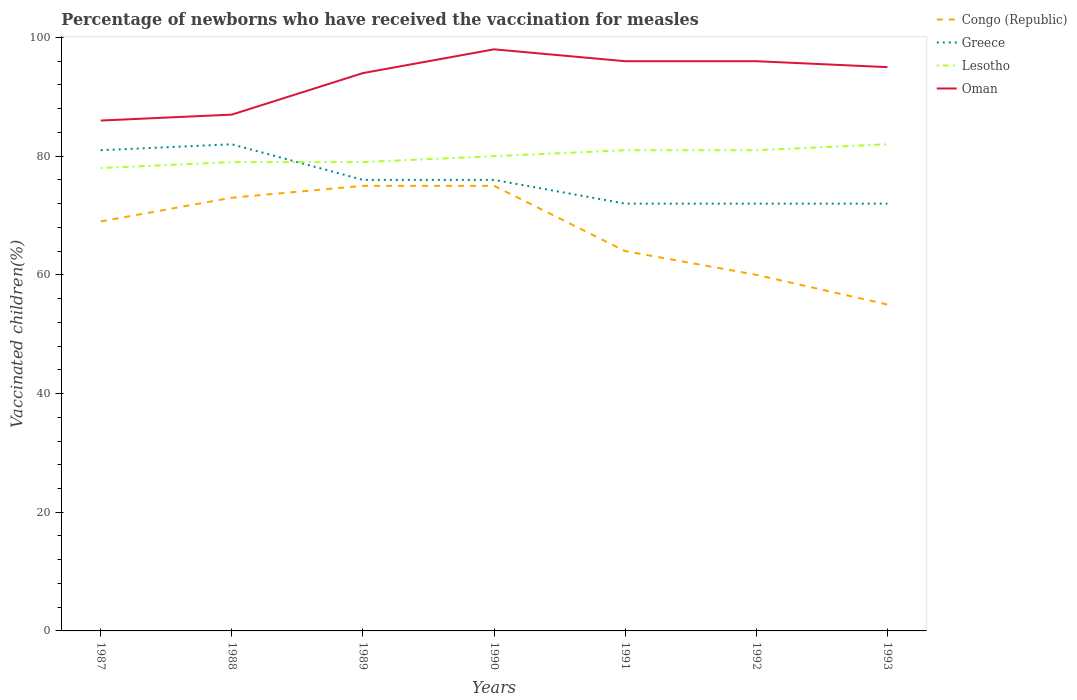Across all years, what is the maximum percentage of vaccinated children in Lesotho?
Your answer should be very brief. 78. In which year was the percentage of vaccinated children in Congo (Republic) maximum?
Provide a succinct answer. 1993. What is the total percentage of vaccinated children in Oman in the graph?
Make the answer very short. -1. What is the difference between the highest and the second highest percentage of vaccinated children in Lesotho?
Make the answer very short. 4. What is the difference between the highest and the lowest percentage of vaccinated children in Greece?
Your answer should be compact. 4. Is the percentage of vaccinated children in Lesotho strictly greater than the percentage of vaccinated children in Greece over the years?
Your answer should be compact. No. How many lines are there?
Offer a terse response. 4. How many years are there in the graph?
Make the answer very short. 7. Are the values on the major ticks of Y-axis written in scientific E-notation?
Give a very brief answer. No. How are the legend labels stacked?
Your answer should be compact. Vertical. What is the title of the graph?
Your response must be concise. Percentage of newborns who have received the vaccination for measles. Does "Turks and Caicos Islands" appear as one of the legend labels in the graph?
Offer a terse response. No. What is the label or title of the X-axis?
Give a very brief answer. Years. What is the label or title of the Y-axis?
Provide a succinct answer. Vaccinated children(%). What is the Vaccinated children(%) of Greece in 1987?
Offer a very short reply. 81. What is the Vaccinated children(%) in Lesotho in 1987?
Offer a very short reply. 78. What is the Vaccinated children(%) in Congo (Republic) in 1988?
Your answer should be very brief. 73. What is the Vaccinated children(%) of Lesotho in 1988?
Keep it short and to the point. 79. What is the Vaccinated children(%) in Congo (Republic) in 1989?
Provide a succinct answer. 75. What is the Vaccinated children(%) of Lesotho in 1989?
Provide a succinct answer. 79. What is the Vaccinated children(%) of Oman in 1989?
Provide a succinct answer. 94. What is the Vaccinated children(%) of Lesotho in 1990?
Provide a short and direct response. 80. What is the Vaccinated children(%) in Oman in 1990?
Give a very brief answer. 98. What is the Vaccinated children(%) of Oman in 1991?
Give a very brief answer. 96. What is the Vaccinated children(%) of Congo (Republic) in 1992?
Offer a very short reply. 60. What is the Vaccinated children(%) in Greece in 1992?
Your answer should be very brief. 72. What is the Vaccinated children(%) of Oman in 1992?
Ensure brevity in your answer.  96. What is the Vaccinated children(%) of Lesotho in 1993?
Your response must be concise. 82. What is the Vaccinated children(%) in Oman in 1993?
Your answer should be compact. 95. Across all years, what is the maximum Vaccinated children(%) in Congo (Republic)?
Your response must be concise. 75. Across all years, what is the maximum Vaccinated children(%) of Greece?
Provide a short and direct response. 82. Across all years, what is the maximum Vaccinated children(%) of Lesotho?
Provide a succinct answer. 82. Across all years, what is the maximum Vaccinated children(%) of Oman?
Provide a short and direct response. 98. Across all years, what is the minimum Vaccinated children(%) in Congo (Republic)?
Make the answer very short. 55. What is the total Vaccinated children(%) of Congo (Republic) in the graph?
Provide a succinct answer. 471. What is the total Vaccinated children(%) of Greece in the graph?
Provide a succinct answer. 531. What is the total Vaccinated children(%) of Lesotho in the graph?
Ensure brevity in your answer.  560. What is the total Vaccinated children(%) of Oman in the graph?
Offer a very short reply. 652. What is the difference between the Vaccinated children(%) in Greece in 1987 and that in 1988?
Your answer should be very brief. -1. What is the difference between the Vaccinated children(%) in Lesotho in 1987 and that in 1988?
Offer a very short reply. -1. What is the difference between the Vaccinated children(%) in Oman in 1987 and that in 1988?
Provide a succinct answer. -1. What is the difference between the Vaccinated children(%) in Congo (Republic) in 1987 and that in 1989?
Keep it short and to the point. -6. What is the difference between the Vaccinated children(%) in Congo (Republic) in 1987 and that in 1990?
Your answer should be very brief. -6. What is the difference between the Vaccinated children(%) in Congo (Republic) in 1987 and that in 1991?
Your answer should be compact. 5. What is the difference between the Vaccinated children(%) in Lesotho in 1987 and that in 1992?
Provide a succinct answer. -3. What is the difference between the Vaccinated children(%) in Oman in 1987 and that in 1992?
Ensure brevity in your answer.  -10. What is the difference between the Vaccinated children(%) of Congo (Republic) in 1987 and that in 1993?
Offer a terse response. 14. What is the difference between the Vaccinated children(%) of Greece in 1987 and that in 1993?
Give a very brief answer. 9. What is the difference between the Vaccinated children(%) in Oman in 1987 and that in 1993?
Provide a succinct answer. -9. What is the difference between the Vaccinated children(%) in Lesotho in 1988 and that in 1989?
Offer a terse response. 0. What is the difference between the Vaccinated children(%) in Oman in 1988 and that in 1989?
Ensure brevity in your answer.  -7. What is the difference between the Vaccinated children(%) in Greece in 1988 and that in 1990?
Offer a terse response. 6. What is the difference between the Vaccinated children(%) of Lesotho in 1988 and that in 1990?
Offer a very short reply. -1. What is the difference between the Vaccinated children(%) of Oman in 1988 and that in 1990?
Provide a succinct answer. -11. What is the difference between the Vaccinated children(%) of Congo (Republic) in 1988 and that in 1991?
Provide a short and direct response. 9. What is the difference between the Vaccinated children(%) in Lesotho in 1988 and that in 1991?
Offer a very short reply. -2. What is the difference between the Vaccinated children(%) in Oman in 1988 and that in 1991?
Make the answer very short. -9. What is the difference between the Vaccinated children(%) in Congo (Republic) in 1988 and that in 1992?
Provide a succinct answer. 13. What is the difference between the Vaccinated children(%) of Oman in 1988 and that in 1992?
Make the answer very short. -9. What is the difference between the Vaccinated children(%) in Lesotho in 1988 and that in 1993?
Give a very brief answer. -3. What is the difference between the Vaccinated children(%) in Oman in 1988 and that in 1993?
Offer a terse response. -8. What is the difference between the Vaccinated children(%) of Lesotho in 1989 and that in 1990?
Make the answer very short. -1. What is the difference between the Vaccinated children(%) in Oman in 1989 and that in 1990?
Your response must be concise. -4. What is the difference between the Vaccinated children(%) of Congo (Republic) in 1989 and that in 1992?
Offer a terse response. 15. What is the difference between the Vaccinated children(%) in Congo (Republic) in 1989 and that in 1993?
Your answer should be very brief. 20. What is the difference between the Vaccinated children(%) of Greece in 1989 and that in 1993?
Give a very brief answer. 4. What is the difference between the Vaccinated children(%) in Lesotho in 1989 and that in 1993?
Offer a terse response. -3. What is the difference between the Vaccinated children(%) in Congo (Republic) in 1990 and that in 1991?
Ensure brevity in your answer.  11. What is the difference between the Vaccinated children(%) in Lesotho in 1990 and that in 1991?
Provide a short and direct response. -1. What is the difference between the Vaccinated children(%) of Lesotho in 1990 and that in 1992?
Your response must be concise. -1. What is the difference between the Vaccinated children(%) of Congo (Republic) in 1990 and that in 1993?
Provide a succinct answer. 20. What is the difference between the Vaccinated children(%) of Congo (Republic) in 1991 and that in 1992?
Your response must be concise. 4. What is the difference between the Vaccinated children(%) in Greece in 1991 and that in 1993?
Give a very brief answer. 0. What is the difference between the Vaccinated children(%) of Congo (Republic) in 1987 and the Vaccinated children(%) of Greece in 1988?
Give a very brief answer. -13. What is the difference between the Vaccinated children(%) of Congo (Republic) in 1987 and the Vaccinated children(%) of Oman in 1988?
Your response must be concise. -18. What is the difference between the Vaccinated children(%) of Greece in 1987 and the Vaccinated children(%) of Lesotho in 1988?
Provide a short and direct response. 2. What is the difference between the Vaccinated children(%) of Congo (Republic) in 1987 and the Vaccinated children(%) of Oman in 1989?
Your answer should be compact. -25. What is the difference between the Vaccinated children(%) in Greece in 1987 and the Vaccinated children(%) in Lesotho in 1989?
Ensure brevity in your answer.  2. What is the difference between the Vaccinated children(%) in Lesotho in 1987 and the Vaccinated children(%) in Oman in 1989?
Make the answer very short. -16. What is the difference between the Vaccinated children(%) of Congo (Republic) in 1987 and the Vaccinated children(%) of Greece in 1990?
Ensure brevity in your answer.  -7. What is the difference between the Vaccinated children(%) in Congo (Republic) in 1987 and the Vaccinated children(%) in Lesotho in 1990?
Your response must be concise. -11. What is the difference between the Vaccinated children(%) of Lesotho in 1987 and the Vaccinated children(%) of Oman in 1990?
Offer a very short reply. -20. What is the difference between the Vaccinated children(%) in Congo (Republic) in 1987 and the Vaccinated children(%) in Lesotho in 1991?
Make the answer very short. -12. What is the difference between the Vaccinated children(%) in Congo (Republic) in 1987 and the Vaccinated children(%) in Greece in 1992?
Your answer should be very brief. -3. What is the difference between the Vaccinated children(%) in Congo (Republic) in 1987 and the Vaccinated children(%) in Oman in 1992?
Keep it short and to the point. -27. What is the difference between the Vaccinated children(%) of Lesotho in 1987 and the Vaccinated children(%) of Oman in 1992?
Provide a short and direct response. -18. What is the difference between the Vaccinated children(%) in Congo (Republic) in 1987 and the Vaccinated children(%) in Greece in 1993?
Provide a succinct answer. -3. What is the difference between the Vaccinated children(%) of Congo (Republic) in 1987 and the Vaccinated children(%) of Lesotho in 1993?
Your response must be concise. -13. What is the difference between the Vaccinated children(%) of Greece in 1987 and the Vaccinated children(%) of Lesotho in 1993?
Ensure brevity in your answer.  -1. What is the difference between the Vaccinated children(%) in Greece in 1987 and the Vaccinated children(%) in Oman in 1993?
Ensure brevity in your answer.  -14. What is the difference between the Vaccinated children(%) of Congo (Republic) in 1988 and the Vaccinated children(%) of Greece in 1989?
Offer a very short reply. -3. What is the difference between the Vaccinated children(%) in Congo (Republic) in 1988 and the Vaccinated children(%) in Oman in 1989?
Keep it short and to the point. -21. What is the difference between the Vaccinated children(%) of Greece in 1988 and the Vaccinated children(%) of Lesotho in 1989?
Make the answer very short. 3. What is the difference between the Vaccinated children(%) of Lesotho in 1988 and the Vaccinated children(%) of Oman in 1989?
Your answer should be compact. -15. What is the difference between the Vaccinated children(%) of Congo (Republic) in 1988 and the Vaccinated children(%) of Greece in 1990?
Offer a very short reply. -3. What is the difference between the Vaccinated children(%) of Lesotho in 1988 and the Vaccinated children(%) of Oman in 1990?
Offer a very short reply. -19. What is the difference between the Vaccinated children(%) in Congo (Republic) in 1988 and the Vaccinated children(%) in Lesotho in 1991?
Offer a terse response. -8. What is the difference between the Vaccinated children(%) of Greece in 1988 and the Vaccinated children(%) of Oman in 1991?
Provide a succinct answer. -14. What is the difference between the Vaccinated children(%) in Lesotho in 1988 and the Vaccinated children(%) in Oman in 1991?
Your answer should be very brief. -17. What is the difference between the Vaccinated children(%) of Congo (Republic) in 1988 and the Vaccinated children(%) of Greece in 1992?
Provide a succinct answer. 1. What is the difference between the Vaccinated children(%) in Congo (Republic) in 1988 and the Vaccinated children(%) in Oman in 1992?
Make the answer very short. -23. What is the difference between the Vaccinated children(%) in Greece in 1988 and the Vaccinated children(%) in Oman in 1992?
Ensure brevity in your answer.  -14. What is the difference between the Vaccinated children(%) of Congo (Republic) in 1988 and the Vaccinated children(%) of Oman in 1993?
Provide a short and direct response. -22. What is the difference between the Vaccinated children(%) of Congo (Republic) in 1989 and the Vaccinated children(%) of Greece in 1990?
Offer a terse response. -1. What is the difference between the Vaccinated children(%) in Congo (Republic) in 1989 and the Vaccinated children(%) in Oman in 1990?
Provide a succinct answer. -23. What is the difference between the Vaccinated children(%) in Greece in 1989 and the Vaccinated children(%) in Oman in 1990?
Keep it short and to the point. -22. What is the difference between the Vaccinated children(%) in Lesotho in 1989 and the Vaccinated children(%) in Oman in 1990?
Keep it short and to the point. -19. What is the difference between the Vaccinated children(%) of Congo (Republic) in 1989 and the Vaccinated children(%) of Lesotho in 1991?
Provide a short and direct response. -6. What is the difference between the Vaccinated children(%) of Congo (Republic) in 1989 and the Vaccinated children(%) of Oman in 1991?
Your answer should be very brief. -21. What is the difference between the Vaccinated children(%) in Congo (Republic) in 1989 and the Vaccinated children(%) in Greece in 1992?
Your answer should be compact. 3. What is the difference between the Vaccinated children(%) in Congo (Republic) in 1989 and the Vaccinated children(%) in Lesotho in 1992?
Give a very brief answer. -6. What is the difference between the Vaccinated children(%) in Congo (Republic) in 1989 and the Vaccinated children(%) in Oman in 1992?
Your answer should be compact. -21. What is the difference between the Vaccinated children(%) in Greece in 1989 and the Vaccinated children(%) in Oman in 1992?
Make the answer very short. -20. What is the difference between the Vaccinated children(%) of Congo (Republic) in 1989 and the Vaccinated children(%) of Greece in 1993?
Offer a very short reply. 3. What is the difference between the Vaccinated children(%) in Congo (Republic) in 1989 and the Vaccinated children(%) in Lesotho in 1993?
Provide a succinct answer. -7. What is the difference between the Vaccinated children(%) in Congo (Republic) in 1989 and the Vaccinated children(%) in Oman in 1993?
Give a very brief answer. -20. What is the difference between the Vaccinated children(%) of Greece in 1989 and the Vaccinated children(%) of Lesotho in 1993?
Keep it short and to the point. -6. What is the difference between the Vaccinated children(%) in Greece in 1989 and the Vaccinated children(%) in Oman in 1993?
Your answer should be compact. -19. What is the difference between the Vaccinated children(%) of Lesotho in 1989 and the Vaccinated children(%) of Oman in 1993?
Give a very brief answer. -16. What is the difference between the Vaccinated children(%) in Congo (Republic) in 1990 and the Vaccinated children(%) in Greece in 1991?
Your response must be concise. 3. What is the difference between the Vaccinated children(%) of Lesotho in 1990 and the Vaccinated children(%) of Oman in 1991?
Your answer should be very brief. -16. What is the difference between the Vaccinated children(%) in Congo (Republic) in 1990 and the Vaccinated children(%) in Greece in 1992?
Your answer should be very brief. 3. What is the difference between the Vaccinated children(%) in Congo (Republic) in 1990 and the Vaccinated children(%) in Oman in 1992?
Ensure brevity in your answer.  -21. What is the difference between the Vaccinated children(%) of Greece in 1990 and the Vaccinated children(%) of Oman in 1992?
Ensure brevity in your answer.  -20. What is the difference between the Vaccinated children(%) of Congo (Republic) in 1990 and the Vaccinated children(%) of Oman in 1993?
Ensure brevity in your answer.  -20. What is the difference between the Vaccinated children(%) of Greece in 1990 and the Vaccinated children(%) of Lesotho in 1993?
Ensure brevity in your answer.  -6. What is the difference between the Vaccinated children(%) in Greece in 1990 and the Vaccinated children(%) in Oman in 1993?
Offer a terse response. -19. What is the difference between the Vaccinated children(%) in Congo (Republic) in 1991 and the Vaccinated children(%) in Greece in 1992?
Your response must be concise. -8. What is the difference between the Vaccinated children(%) in Congo (Republic) in 1991 and the Vaccinated children(%) in Oman in 1992?
Offer a very short reply. -32. What is the difference between the Vaccinated children(%) of Congo (Republic) in 1991 and the Vaccinated children(%) of Oman in 1993?
Your answer should be compact. -31. What is the difference between the Vaccinated children(%) of Greece in 1991 and the Vaccinated children(%) of Oman in 1993?
Ensure brevity in your answer.  -23. What is the difference between the Vaccinated children(%) of Lesotho in 1991 and the Vaccinated children(%) of Oman in 1993?
Your response must be concise. -14. What is the difference between the Vaccinated children(%) in Congo (Republic) in 1992 and the Vaccinated children(%) in Greece in 1993?
Your answer should be compact. -12. What is the difference between the Vaccinated children(%) in Congo (Republic) in 1992 and the Vaccinated children(%) in Oman in 1993?
Keep it short and to the point. -35. What is the difference between the Vaccinated children(%) in Greece in 1992 and the Vaccinated children(%) in Lesotho in 1993?
Keep it short and to the point. -10. What is the difference between the Vaccinated children(%) of Lesotho in 1992 and the Vaccinated children(%) of Oman in 1993?
Your answer should be very brief. -14. What is the average Vaccinated children(%) in Congo (Republic) per year?
Give a very brief answer. 67.29. What is the average Vaccinated children(%) of Greece per year?
Ensure brevity in your answer.  75.86. What is the average Vaccinated children(%) in Oman per year?
Offer a terse response. 93.14. In the year 1987, what is the difference between the Vaccinated children(%) of Greece and Vaccinated children(%) of Oman?
Keep it short and to the point. -5. In the year 1988, what is the difference between the Vaccinated children(%) in Greece and Vaccinated children(%) in Lesotho?
Offer a terse response. 3. In the year 1989, what is the difference between the Vaccinated children(%) in Congo (Republic) and Vaccinated children(%) in Oman?
Make the answer very short. -19. In the year 1989, what is the difference between the Vaccinated children(%) of Greece and Vaccinated children(%) of Oman?
Provide a succinct answer. -18. In the year 1989, what is the difference between the Vaccinated children(%) of Lesotho and Vaccinated children(%) of Oman?
Offer a terse response. -15. In the year 1990, what is the difference between the Vaccinated children(%) of Congo (Republic) and Vaccinated children(%) of Lesotho?
Offer a terse response. -5. In the year 1990, what is the difference between the Vaccinated children(%) in Greece and Vaccinated children(%) in Lesotho?
Provide a short and direct response. -4. In the year 1990, what is the difference between the Vaccinated children(%) in Greece and Vaccinated children(%) in Oman?
Keep it short and to the point. -22. In the year 1991, what is the difference between the Vaccinated children(%) in Congo (Republic) and Vaccinated children(%) in Greece?
Offer a very short reply. -8. In the year 1991, what is the difference between the Vaccinated children(%) in Congo (Republic) and Vaccinated children(%) in Lesotho?
Your answer should be compact. -17. In the year 1991, what is the difference between the Vaccinated children(%) of Congo (Republic) and Vaccinated children(%) of Oman?
Your answer should be very brief. -32. In the year 1991, what is the difference between the Vaccinated children(%) in Greece and Vaccinated children(%) in Lesotho?
Your answer should be compact. -9. In the year 1991, what is the difference between the Vaccinated children(%) of Greece and Vaccinated children(%) of Oman?
Offer a very short reply. -24. In the year 1992, what is the difference between the Vaccinated children(%) in Congo (Republic) and Vaccinated children(%) in Oman?
Provide a short and direct response. -36. In the year 1993, what is the difference between the Vaccinated children(%) in Congo (Republic) and Vaccinated children(%) in Greece?
Your answer should be very brief. -17. In the year 1993, what is the difference between the Vaccinated children(%) of Congo (Republic) and Vaccinated children(%) of Lesotho?
Provide a succinct answer. -27. In the year 1993, what is the difference between the Vaccinated children(%) in Greece and Vaccinated children(%) in Lesotho?
Give a very brief answer. -10. In the year 1993, what is the difference between the Vaccinated children(%) of Lesotho and Vaccinated children(%) of Oman?
Your response must be concise. -13. What is the ratio of the Vaccinated children(%) of Congo (Republic) in 1987 to that in 1988?
Ensure brevity in your answer.  0.95. What is the ratio of the Vaccinated children(%) in Greece in 1987 to that in 1988?
Ensure brevity in your answer.  0.99. What is the ratio of the Vaccinated children(%) in Lesotho in 1987 to that in 1988?
Make the answer very short. 0.99. What is the ratio of the Vaccinated children(%) in Oman in 1987 to that in 1988?
Offer a very short reply. 0.99. What is the ratio of the Vaccinated children(%) in Greece in 1987 to that in 1989?
Offer a terse response. 1.07. What is the ratio of the Vaccinated children(%) in Lesotho in 1987 to that in 1989?
Give a very brief answer. 0.99. What is the ratio of the Vaccinated children(%) in Oman in 1987 to that in 1989?
Provide a short and direct response. 0.91. What is the ratio of the Vaccinated children(%) in Congo (Republic) in 1987 to that in 1990?
Offer a very short reply. 0.92. What is the ratio of the Vaccinated children(%) in Greece in 1987 to that in 1990?
Make the answer very short. 1.07. What is the ratio of the Vaccinated children(%) of Lesotho in 1987 to that in 1990?
Provide a short and direct response. 0.97. What is the ratio of the Vaccinated children(%) in Oman in 1987 to that in 1990?
Ensure brevity in your answer.  0.88. What is the ratio of the Vaccinated children(%) in Congo (Republic) in 1987 to that in 1991?
Your answer should be compact. 1.08. What is the ratio of the Vaccinated children(%) in Oman in 1987 to that in 1991?
Offer a very short reply. 0.9. What is the ratio of the Vaccinated children(%) of Congo (Republic) in 1987 to that in 1992?
Provide a short and direct response. 1.15. What is the ratio of the Vaccinated children(%) of Oman in 1987 to that in 1992?
Your response must be concise. 0.9. What is the ratio of the Vaccinated children(%) in Congo (Republic) in 1987 to that in 1993?
Provide a succinct answer. 1.25. What is the ratio of the Vaccinated children(%) in Lesotho in 1987 to that in 1993?
Provide a short and direct response. 0.95. What is the ratio of the Vaccinated children(%) of Oman in 1987 to that in 1993?
Your answer should be compact. 0.91. What is the ratio of the Vaccinated children(%) in Congo (Republic) in 1988 to that in 1989?
Keep it short and to the point. 0.97. What is the ratio of the Vaccinated children(%) of Greece in 1988 to that in 1989?
Give a very brief answer. 1.08. What is the ratio of the Vaccinated children(%) in Oman in 1988 to that in 1989?
Your answer should be compact. 0.93. What is the ratio of the Vaccinated children(%) in Congo (Republic) in 1988 to that in 1990?
Your answer should be compact. 0.97. What is the ratio of the Vaccinated children(%) in Greece in 1988 to that in 1990?
Make the answer very short. 1.08. What is the ratio of the Vaccinated children(%) of Lesotho in 1988 to that in 1990?
Your response must be concise. 0.99. What is the ratio of the Vaccinated children(%) of Oman in 1988 to that in 1990?
Offer a terse response. 0.89. What is the ratio of the Vaccinated children(%) of Congo (Republic) in 1988 to that in 1991?
Ensure brevity in your answer.  1.14. What is the ratio of the Vaccinated children(%) in Greece in 1988 to that in 1991?
Your response must be concise. 1.14. What is the ratio of the Vaccinated children(%) in Lesotho in 1988 to that in 1991?
Offer a terse response. 0.98. What is the ratio of the Vaccinated children(%) in Oman in 1988 to that in 1991?
Make the answer very short. 0.91. What is the ratio of the Vaccinated children(%) in Congo (Republic) in 1988 to that in 1992?
Offer a terse response. 1.22. What is the ratio of the Vaccinated children(%) of Greece in 1988 to that in 1992?
Your response must be concise. 1.14. What is the ratio of the Vaccinated children(%) in Lesotho in 1988 to that in 1992?
Provide a succinct answer. 0.98. What is the ratio of the Vaccinated children(%) in Oman in 1988 to that in 1992?
Ensure brevity in your answer.  0.91. What is the ratio of the Vaccinated children(%) in Congo (Republic) in 1988 to that in 1993?
Your answer should be compact. 1.33. What is the ratio of the Vaccinated children(%) in Greece in 1988 to that in 1993?
Offer a very short reply. 1.14. What is the ratio of the Vaccinated children(%) in Lesotho in 1988 to that in 1993?
Provide a short and direct response. 0.96. What is the ratio of the Vaccinated children(%) of Oman in 1988 to that in 1993?
Your response must be concise. 0.92. What is the ratio of the Vaccinated children(%) in Congo (Republic) in 1989 to that in 1990?
Ensure brevity in your answer.  1. What is the ratio of the Vaccinated children(%) in Lesotho in 1989 to that in 1990?
Ensure brevity in your answer.  0.99. What is the ratio of the Vaccinated children(%) in Oman in 1989 to that in 1990?
Provide a succinct answer. 0.96. What is the ratio of the Vaccinated children(%) in Congo (Republic) in 1989 to that in 1991?
Keep it short and to the point. 1.17. What is the ratio of the Vaccinated children(%) of Greece in 1989 to that in 1991?
Give a very brief answer. 1.06. What is the ratio of the Vaccinated children(%) of Lesotho in 1989 to that in 1991?
Make the answer very short. 0.98. What is the ratio of the Vaccinated children(%) in Oman in 1989 to that in 1991?
Provide a succinct answer. 0.98. What is the ratio of the Vaccinated children(%) of Congo (Republic) in 1989 to that in 1992?
Your answer should be very brief. 1.25. What is the ratio of the Vaccinated children(%) of Greece in 1989 to that in 1992?
Your answer should be compact. 1.06. What is the ratio of the Vaccinated children(%) of Lesotho in 1989 to that in 1992?
Offer a terse response. 0.98. What is the ratio of the Vaccinated children(%) in Oman in 1989 to that in 1992?
Make the answer very short. 0.98. What is the ratio of the Vaccinated children(%) in Congo (Republic) in 1989 to that in 1993?
Offer a terse response. 1.36. What is the ratio of the Vaccinated children(%) of Greece in 1989 to that in 1993?
Offer a terse response. 1.06. What is the ratio of the Vaccinated children(%) of Lesotho in 1989 to that in 1993?
Offer a terse response. 0.96. What is the ratio of the Vaccinated children(%) in Oman in 1989 to that in 1993?
Keep it short and to the point. 0.99. What is the ratio of the Vaccinated children(%) of Congo (Republic) in 1990 to that in 1991?
Your answer should be compact. 1.17. What is the ratio of the Vaccinated children(%) of Greece in 1990 to that in 1991?
Provide a short and direct response. 1.06. What is the ratio of the Vaccinated children(%) in Lesotho in 1990 to that in 1991?
Provide a short and direct response. 0.99. What is the ratio of the Vaccinated children(%) in Oman in 1990 to that in 1991?
Make the answer very short. 1.02. What is the ratio of the Vaccinated children(%) in Congo (Republic) in 1990 to that in 1992?
Your answer should be very brief. 1.25. What is the ratio of the Vaccinated children(%) in Greece in 1990 to that in 1992?
Provide a short and direct response. 1.06. What is the ratio of the Vaccinated children(%) in Lesotho in 1990 to that in 1992?
Keep it short and to the point. 0.99. What is the ratio of the Vaccinated children(%) of Oman in 1990 to that in 1992?
Provide a succinct answer. 1.02. What is the ratio of the Vaccinated children(%) of Congo (Republic) in 1990 to that in 1993?
Your response must be concise. 1.36. What is the ratio of the Vaccinated children(%) of Greece in 1990 to that in 1993?
Offer a terse response. 1.06. What is the ratio of the Vaccinated children(%) in Lesotho in 1990 to that in 1993?
Offer a terse response. 0.98. What is the ratio of the Vaccinated children(%) of Oman in 1990 to that in 1993?
Provide a short and direct response. 1.03. What is the ratio of the Vaccinated children(%) of Congo (Republic) in 1991 to that in 1992?
Give a very brief answer. 1.07. What is the ratio of the Vaccinated children(%) of Greece in 1991 to that in 1992?
Ensure brevity in your answer.  1. What is the ratio of the Vaccinated children(%) in Lesotho in 1991 to that in 1992?
Your answer should be very brief. 1. What is the ratio of the Vaccinated children(%) in Oman in 1991 to that in 1992?
Offer a terse response. 1. What is the ratio of the Vaccinated children(%) in Congo (Republic) in 1991 to that in 1993?
Provide a short and direct response. 1.16. What is the ratio of the Vaccinated children(%) of Lesotho in 1991 to that in 1993?
Make the answer very short. 0.99. What is the ratio of the Vaccinated children(%) of Oman in 1991 to that in 1993?
Make the answer very short. 1.01. What is the ratio of the Vaccinated children(%) in Greece in 1992 to that in 1993?
Ensure brevity in your answer.  1. What is the ratio of the Vaccinated children(%) in Lesotho in 1992 to that in 1993?
Provide a succinct answer. 0.99. What is the ratio of the Vaccinated children(%) of Oman in 1992 to that in 1993?
Provide a succinct answer. 1.01. What is the difference between the highest and the second highest Vaccinated children(%) of Greece?
Give a very brief answer. 1. What is the difference between the highest and the second highest Vaccinated children(%) of Oman?
Your answer should be very brief. 2. What is the difference between the highest and the lowest Vaccinated children(%) in Congo (Republic)?
Ensure brevity in your answer.  20. What is the difference between the highest and the lowest Vaccinated children(%) in Greece?
Your response must be concise. 10. What is the difference between the highest and the lowest Vaccinated children(%) of Lesotho?
Offer a terse response. 4. 